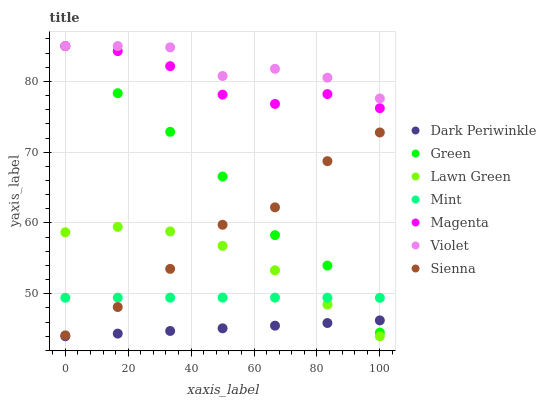Does Dark Periwinkle have the minimum area under the curve?
Answer yes or no. Yes. Does Violet have the maximum area under the curve?
Answer yes or no. Yes. Does Sienna have the minimum area under the curve?
Answer yes or no. No. Does Sienna have the maximum area under the curve?
Answer yes or no. No. Is Dark Periwinkle the smoothest?
Answer yes or no. Yes. Is Green the roughest?
Answer yes or no. Yes. Is Sienna the smoothest?
Answer yes or no. No. Is Sienna the roughest?
Answer yes or no. No. Does Lawn Green have the lowest value?
Answer yes or no. Yes. Does Sienna have the lowest value?
Answer yes or no. No. Does Magenta have the highest value?
Answer yes or no. Yes. Does Sienna have the highest value?
Answer yes or no. No. Is Dark Periwinkle less than Magenta?
Answer yes or no. Yes. Is Green greater than Lawn Green?
Answer yes or no. Yes. Does Sienna intersect Lawn Green?
Answer yes or no. Yes. Is Sienna less than Lawn Green?
Answer yes or no. No. Is Sienna greater than Lawn Green?
Answer yes or no. No. Does Dark Periwinkle intersect Magenta?
Answer yes or no. No. 